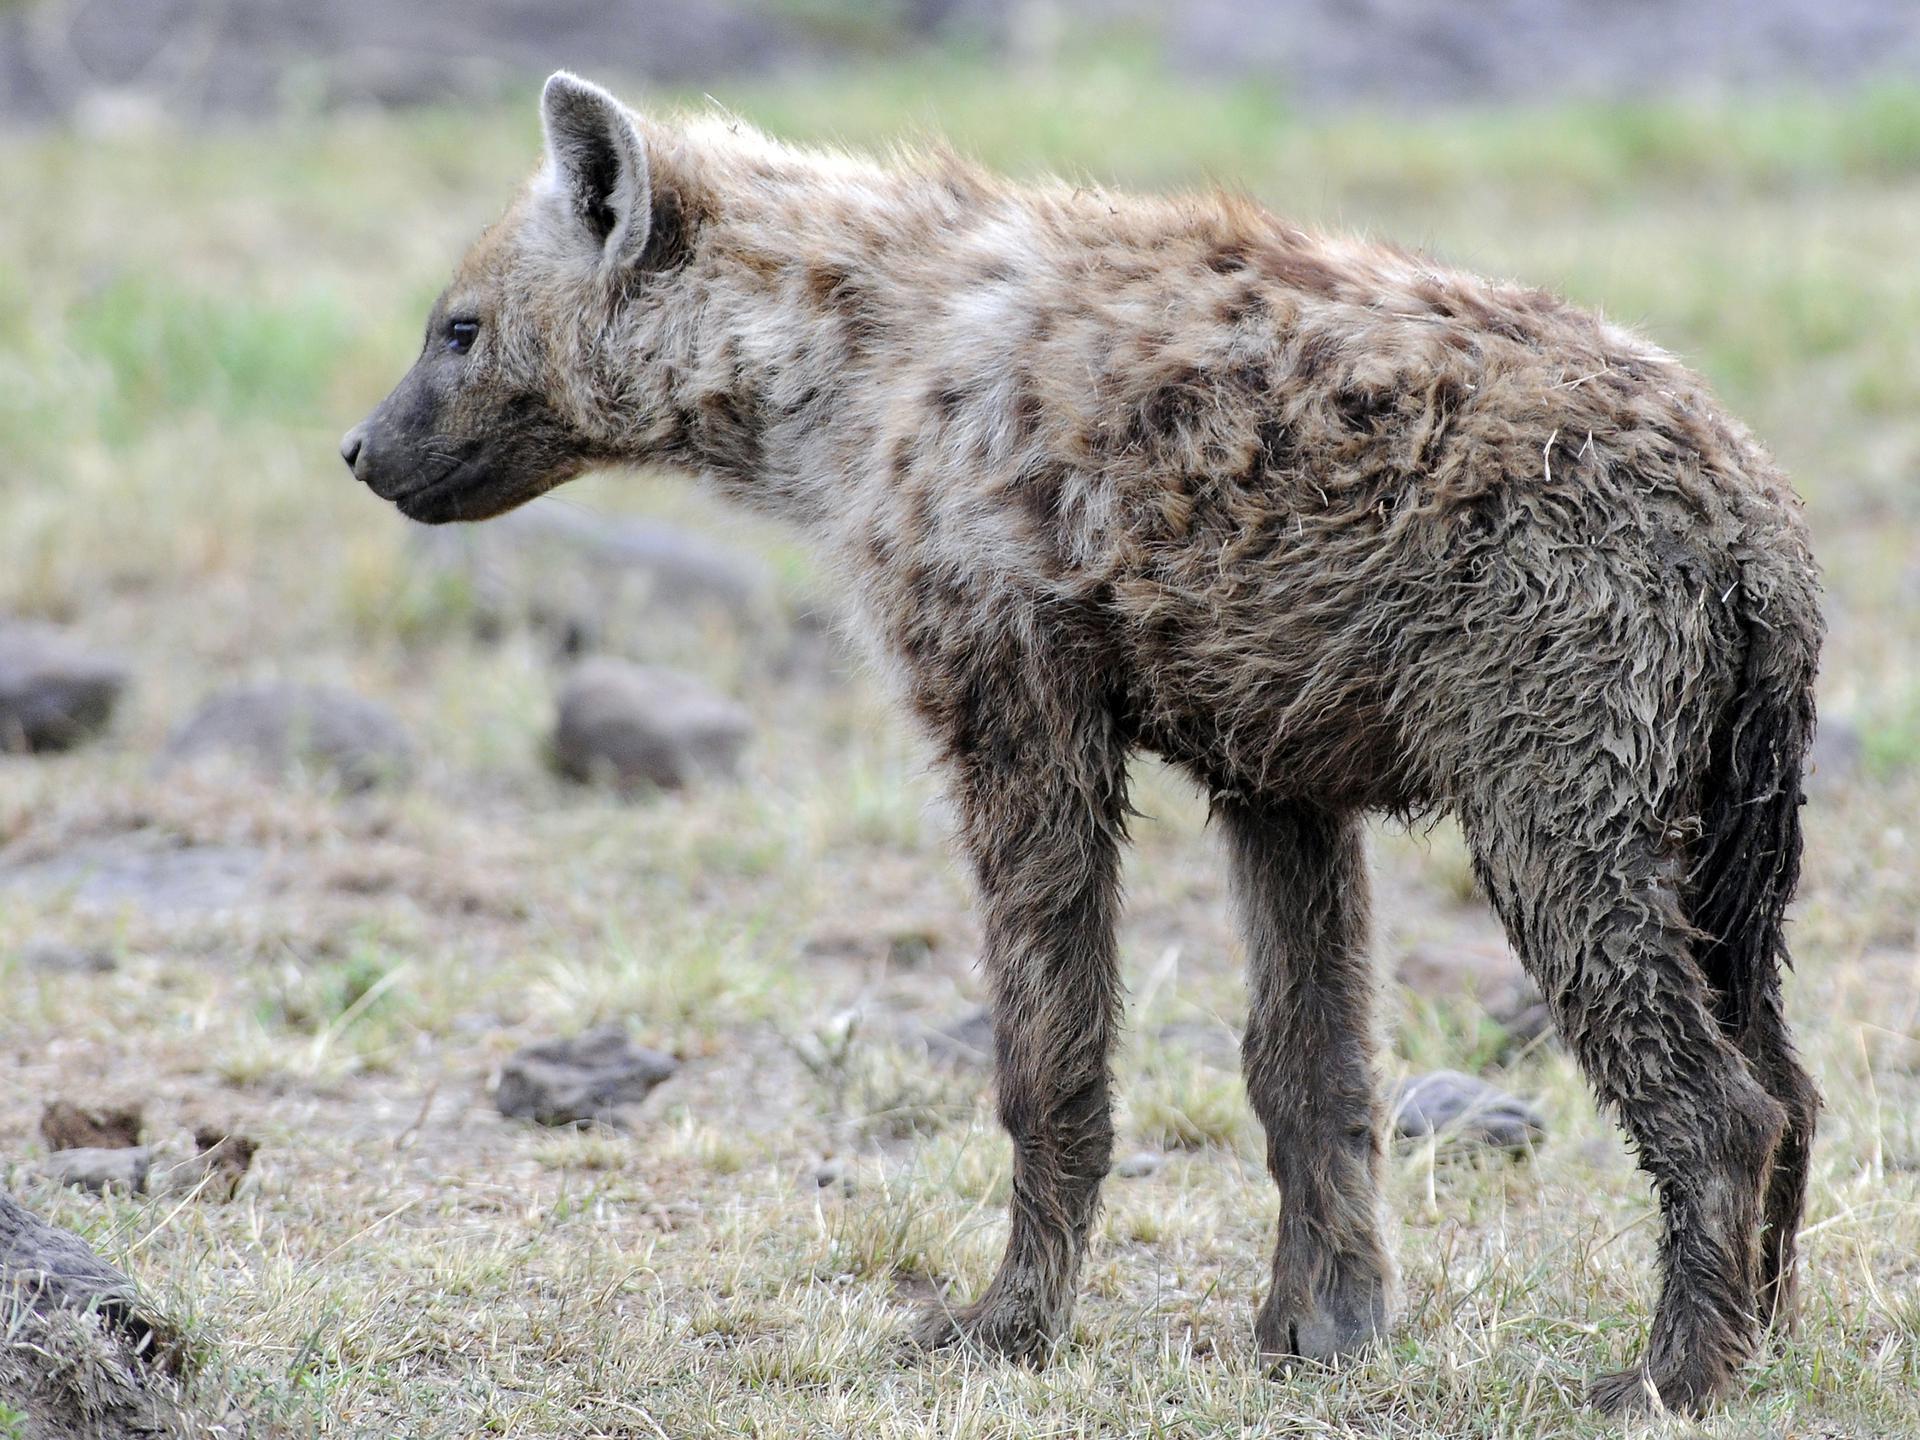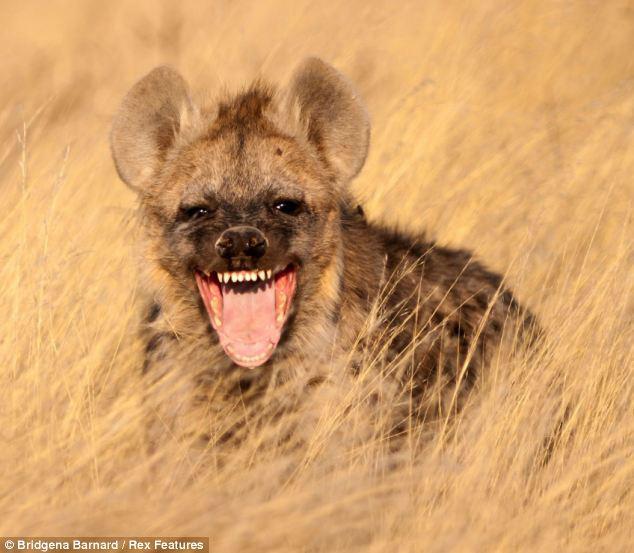The first image is the image on the left, the second image is the image on the right. Evaluate the accuracy of this statement regarding the images: "The left image shows a hyena standing with its body turned leftward, and the right image includes a hyena with opened mouth showing teeth.". Is it true? Answer yes or no. Yes. The first image is the image on the left, the second image is the image on the right. Examine the images to the left and right. Is the description "A hyena is standing in a field in the image on the left." accurate? Answer yes or no. Yes. 